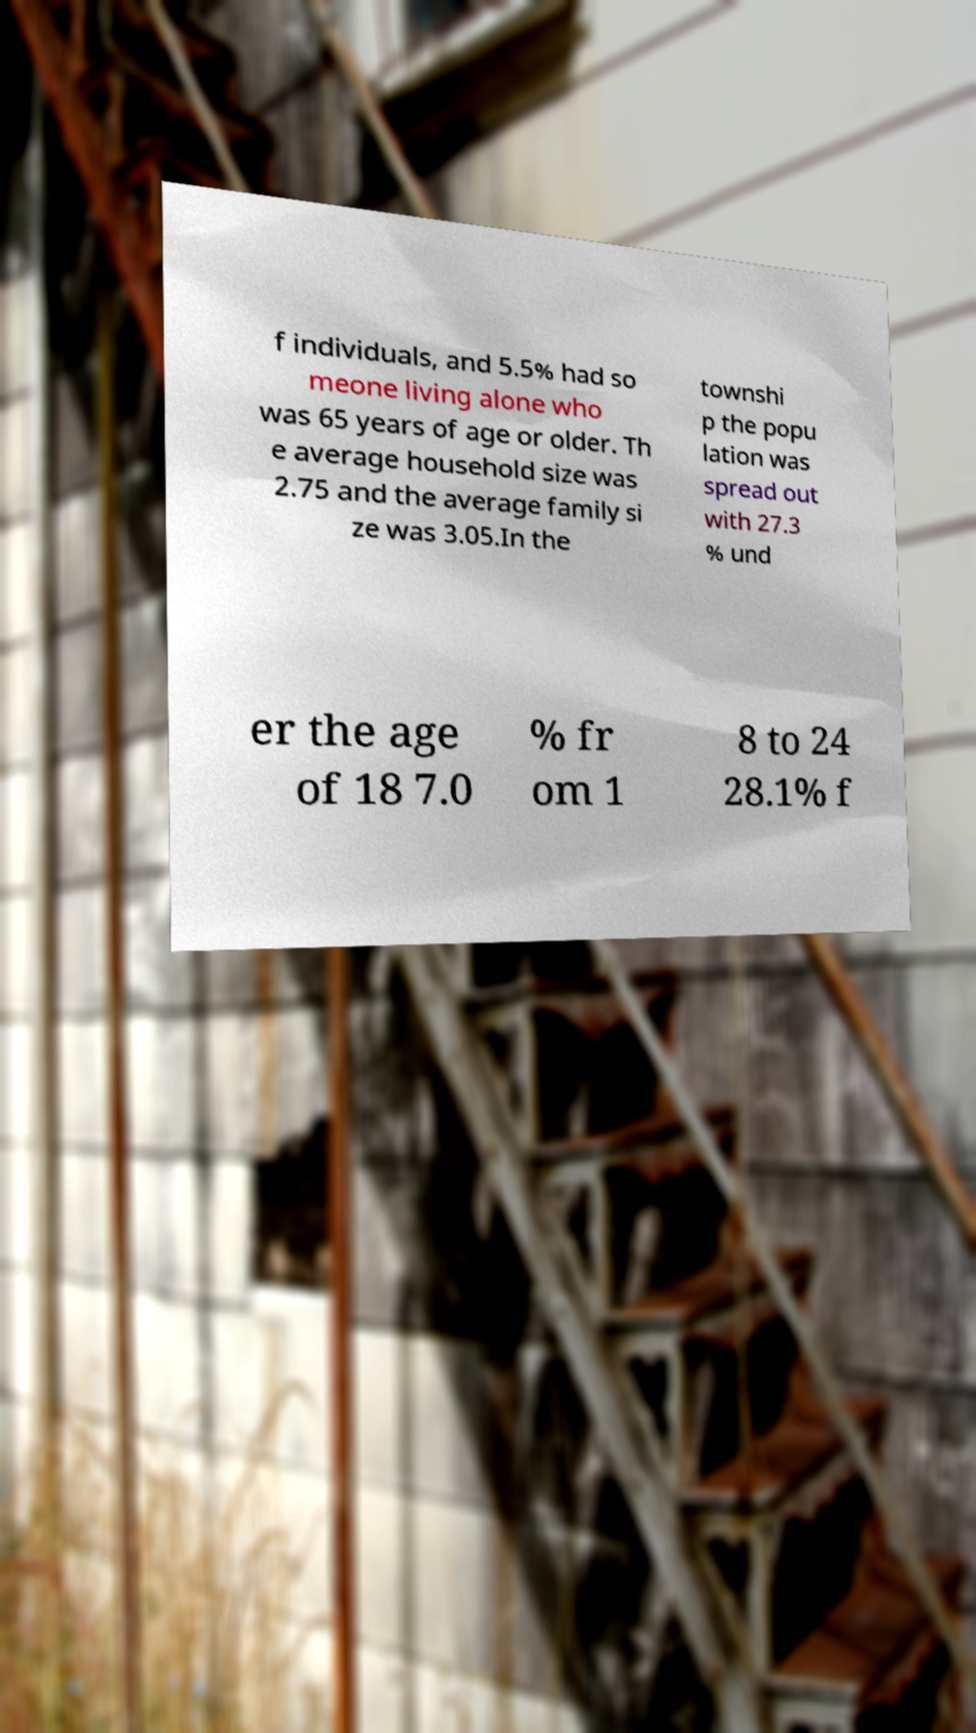Can you read and provide the text displayed in the image?This photo seems to have some interesting text. Can you extract and type it out for me? f individuals, and 5.5% had so meone living alone who was 65 years of age or older. Th e average household size was 2.75 and the average family si ze was 3.05.In the townshi p the popu lation was spread out with 27.3 % und er the age of 18 7.0 % fr om 1 8 to 24 28.1% f 